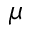<formula> <loc_0><loc_0><loc_500><loc_500>\mu</formula> 